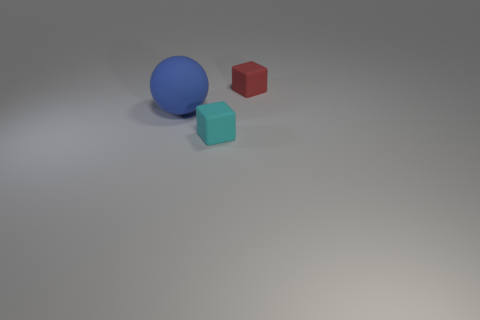Add 1 tiny brown metallic spheres. How many objects exist? 4 Subtract all spheres. How many objects are left? 2 Subtract all small matte cubes. Subtract all tiny green objects. How many objects are left? 1 Add 2 spheres. How many spheres are left? 3 Add 1 blue objects. How many blue objects exist? 2 Subtract 1 red cubes. How many objects are left? 2 